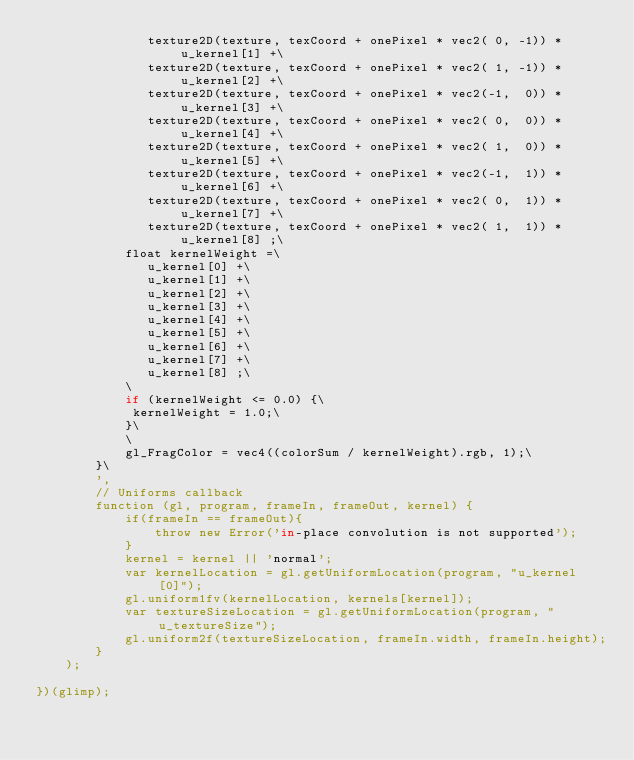<code> <loc_0><loc_0><loc_500><loc_500><_JavaScript_>               texture2D(texture, texCoord + onePixel * vec2( 0, -1)) * u_kernel[1] +\
               texture2D(texture, texCoord + onePixel * vec2( 1, -1)) * u_kernel[2] +\
               texture2D(texture, texCoord + onePixel * vec2(-1,  0)) * u_kernel[3] +\
               texture2D(texture, texCoord + onePixel * vec2( 0,  0)) * u_kernel[4] +\
               texture2D(texture, texCoord + onePixel * vec2( 1,  0)) * u_kernel[5] +\
               texture2D(texture, texCoord + onePixel * vec2(-1,  1)) * u_kernel[6] +\
               texture2D(texture, texCoord + onePixel * vec2( 0,  1)) * u_kernel[7] +\
               texture2D(texture, texCoord + onePixel * vec2( 1,  1)) * u_kernel[8] ;\
            float kernelWeight =\
               u_kernel[0] +\
               u_kernel[1] +\
               u_kernel[2] +\
               u_kernel[3] +\
               u_kernel[4] +\
               u_kernel[5] +\
               u_kernel[6] +\
               u_kernel[7] +\
               u_kernel[8] ;\
            \
            if (kernelWeight <= 0.0) {\
             kernelWeight = 1.0;\
            }\
            \
            gl_FragColor = vec4((colorSum / kernelWeight).rgb, 1);\
        }\
        ',
        // Uniforms callback
        function (gl, program, frameIn, frameOut, kernel) {
            if(frameIn == frameOut){
                throw new Error('in-place convolution is not supported');
            }
            kernel = kernel || 'normal';
            var kernelLocation = gl.getUniformLocation(program, "u_kernel[0]");
            gl.uniform1fv(kernelLocation, kernels[kernel]);
            var textureSizeLocation = gl.getUniformLocation(program, "u_textureSize");
            gl.uniform2f(textureSizeLocation, frameIn.width, frameIn.height);
        }
    );
    
})(glimp);
</code> 